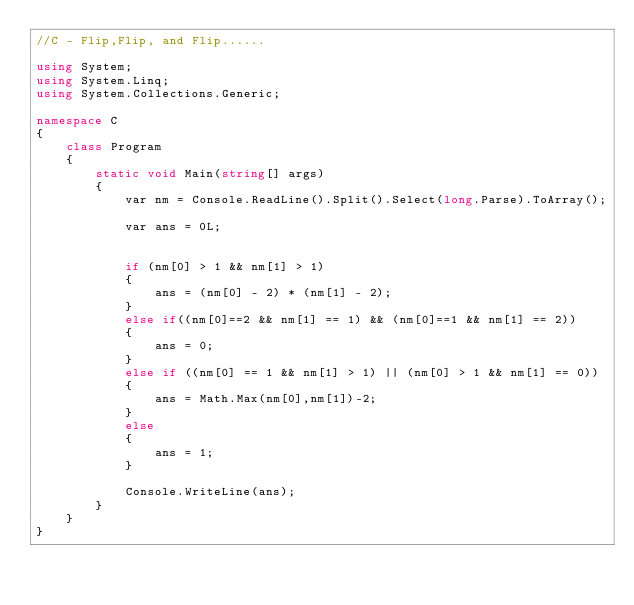Convert code to text. <code><loc_0><loc_0><loc_500><loc_500><_C#_>//C - Flip,Flip, and Flip......

using System;
using System.Linq;
using System.Collections.Generic;

namespace C
{
    class Program
    {
        static void Main(string[] args)
        {
            var nm = Console.ReadLine().Split().Select(long.Parse).ToArray();

            var ans = 0L;


            if (nm[0] > 1 && nm[1] > 1)
            {
                ans = (nm[0] - 2) * (nm[1] - 2);
            }
            else if((nm[0]==2 && nm[1] == 1) && (nm[0]==1 && nm[1] == 2))
            {
                ans = 0;
            }
            else if ((nm[0] == 1 && nm[1] > 1) || (nm[0] > 1 && nm[1] == 0))
            {
                ans = Math.Max(nm[0],nm[1])-2;
            }
            else
            {
                ans = 1;
            }

            Console.WriteLine(ans);
        }
    }
}
</code> 